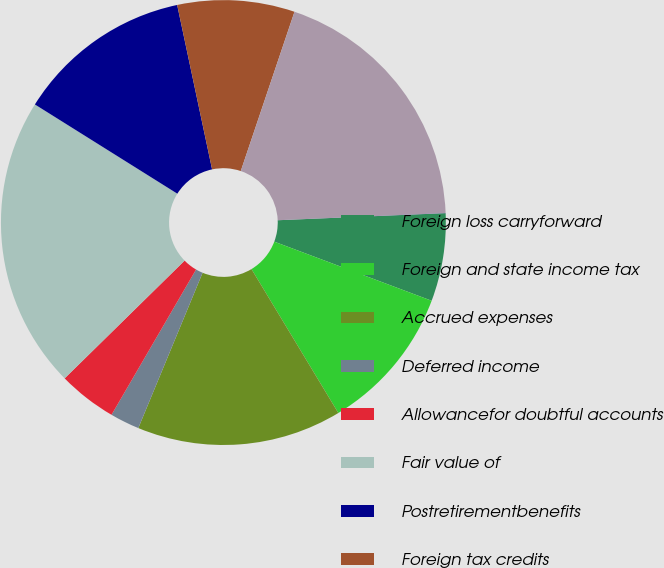<chart> <loc_0><loc_0><loc_500><loc_500><pie_chart><fcel>Foreign loss carryforward<fcel>Foreign and state income tax<fcel>Accrued expenses<fcel>Deferred income<fcel>Allowancefor doubtful accounts<fcel>Fair value of<fcel>Postretirementbenefits<fcel>Foreign tax credits<fcel>Futureforeign tax credits from<fcel>Other<nl><fcel>6.39%<fcel>10.64%<fcel>14.89%<fcel>2.14%<fcel>4.26%<fcel>21.26%<fcel>12.76%<fcel>8.51%<fcel>19.14%<fcel>0.01%<nl></chart> 